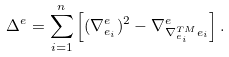Convert formula to latex. <formula><loc_0><loc_0><loc_500><loc_500>\Delta ^ { e } = \sum _ { i = 1 } ^ { n } \left [ ( \nabla ^ { e } _ { e _ { i } } ) ^ { 2 } - \nabla ^ { e } _ { \nabla ^ { T M } _ { e _ { i } } e _ { i } } \right ] .</formula> 